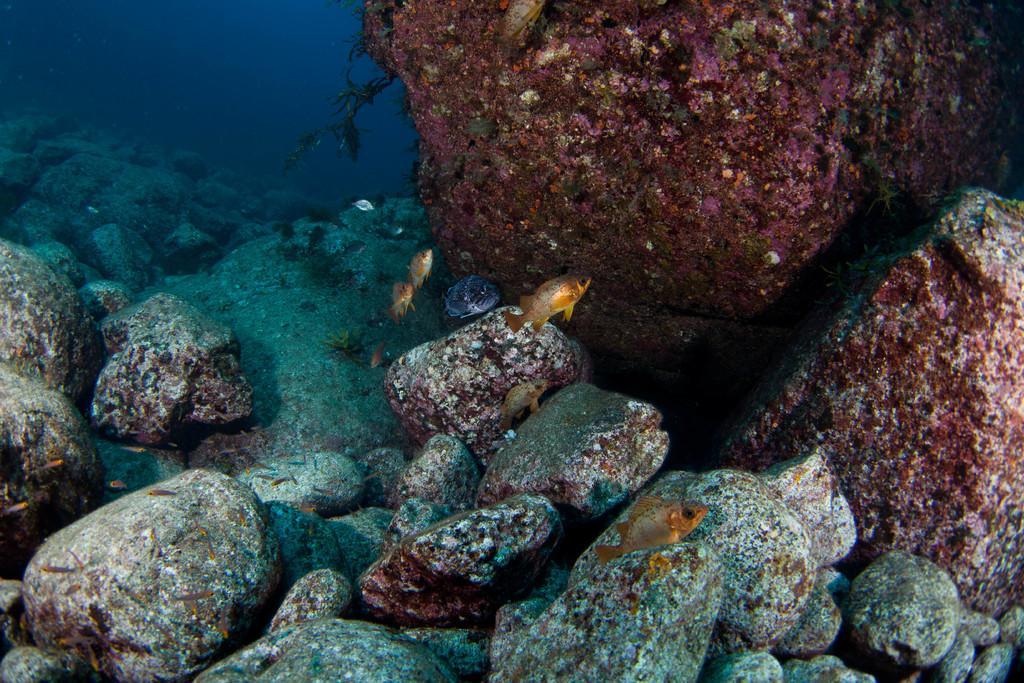In one or two sentences, can you explain what this image depicts? This image is taken inside the water where we can see that there are small fishes in the water. At the bottom there are stones. On the right side there is an algae on the stones. 